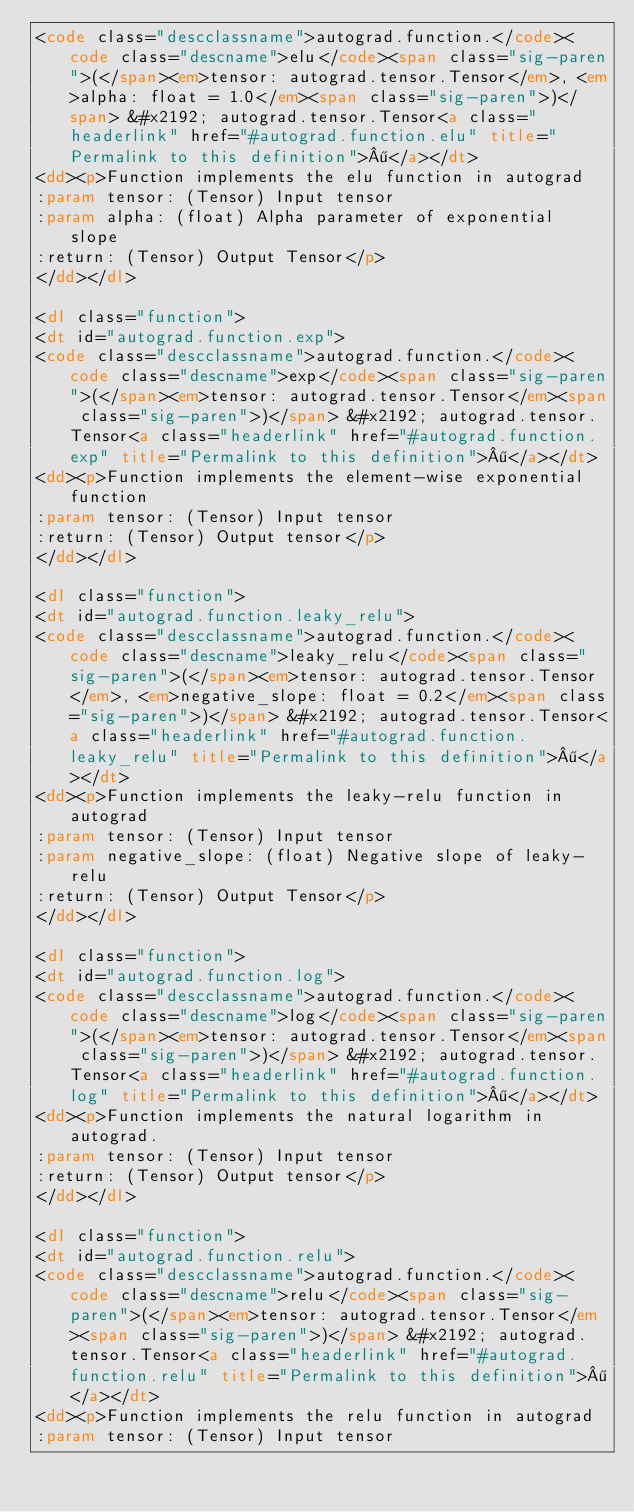<code> <loc_0><loc_0><loc_500><loc_500><_HTML_><code class="descclassname">autograd.function.</code><code class="descname">elu</code><span class="sig-paren">(</span><em>tensor: autograd.tensor.Tensor</em>, <em>alpha: float = 1.0</em><span class="sig-paren">)</span> &#x2192; autograd.tensor.Tensor<a class="headerlink" href="#autograd.function.elu" title="Permalink to this definition">¶</a></dt>
<dd><p>Function implements the elu function in autograd
:param tensor: (Tensor) Input tensor
:param alpha: (float) Alpha parameter of exponential slope
:return: (Tensor) Output Tensor</p>
</dd></dl>

<dl class="function">
<dt id="autograd.function.exp">
<code class="descclassname">autograd.function.</code><code class="descname">exp</code><span class="sig-paren">(</span><em>tensor: autograd.tensor.Tensor</em><span class="sig-paren">)</span> &#x2192; autograd.tensor.Tensor<a class="headerlink" href="#autograd.function.exp" title="Permalink to this definition">¶</a></dt>
<dd><p>Function implements the element-wise exponential function
:param tensor: (Tensor) Input tensor
:return: (Tensor) Output tensor</p>
</dd></dl>

<dl class="function">
<dt id="autograd.function.leaky_relu">
<code class="descclassname">autograd.function.</code><code class="descname">leaky_relu</code><span class="sig-paren">(</span><em>tensor: autograd.tensor.Tensor</em>, <em>negative_slope: float = 0.2</em><span class="sig-paren">)</span> &#x2192; autograd.tensor.Tensor<a class="headerlink" href="#autograd.function.leaky_relu" title="Permalink to this definition">¶</a></dt>
<dd><p>Function implements the leaky-relu function in autograd
:param tensor: (Tensor) Input tensor
:param negative_slope: (float) Negative slope of leaky-relu
:return: (Tensor) Output Tensor</p>
</dd></dl>

<dl class="function">
<dt id="autograd.function.log">
<code class="descclassname">autograd.function.</code><code class="descname">log</code><span class="sig-paren">(</span><em>tensor: autograd.tensor.Tensor</em><span class="sig-paren">)</span> &#x2192; autograd.tensor.Tensor<a class="headerlink" href="#autograd.function.log" title="Permalink to this definition">¶</a></dt>
<dd><p>Function implements the natural logarithm in autograd.
:param tensor: (Tensor) Input tensor
:return: (Tensor) Output tensor</p>
</dd></dl>

<dl class="function">
<dt id="autograd.function.relu">
<code class="descclassname">autograd.function.</code><code class="descname">relu</code><span class="sig-paren">(</span><em>tensor: autograd.tensor.Tensor</em><span class="sig-paren">)</span> &#x2192; autograd.tensor.Tensor<a class="headerlink" href="#autograd.function.relu" title="Permalink to this definition">¶</a></dt>
<dd><p>Function implements the relu function in autograd
:param tensor: (Tensor) Input tensor</code> 